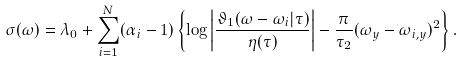Convert formula to latex. <formula><loc_0><loc_0><loc_500><loc_500>\sigma ( \omega ) = \lambda _ { 0 } + \sum _ { i = 1 } ^ { N } ( \alpha _ { i } - 1 ) \left \{ \log \left | \frac { \vartheta _ { 1 } ( \omega - \omega _ { i } | \tau ) } { \eta ( \tau ) } \right | - \frac { \pi } { \tau _ { 2 } } ( \omega _ { y } - \omega _ { i , y } ) ^ { 2 } \right \} .</formula> 